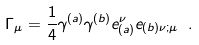Convert formula to latex. <formula><loc_0><loc_0><loc_500><loc_500>\Gamma _ { \mu } = \frac { 1 } { 4 } \gamma ^ { ( a ) } \gamma ^ { ( b ) } e _ { ( a ) } ^ { \nu } e _ { ( b ) \nu ; \mu } \ .</formula> 